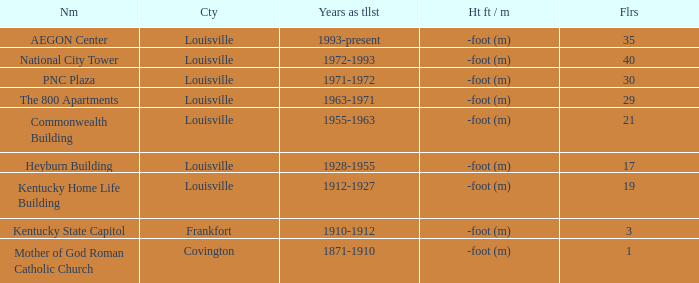In what city does the tallest building have 35 floors? Louisville. 